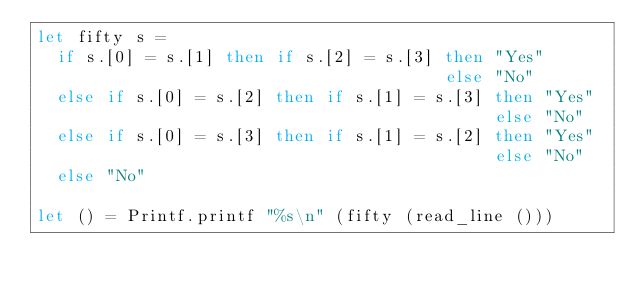Convert code to text. <code><loc_0><loc_0><loc_500><loc_500><_OCaml_>let fifty s =
  if s.[0] = s.[1] then if s.[2] = s.[3] then "Yes"
                                         else "No"
  else if s.[0] = s.[2] then if s.[1] = s.[3] then "Yes"
                                              else "No"
  else if s.[0] = s.[3] then if s.[1] = s.[2] then "Yes"
                                              else "No"
  else "No"

let () = Printf.printf "%s\n" (fifty (read_line ()))</code> 